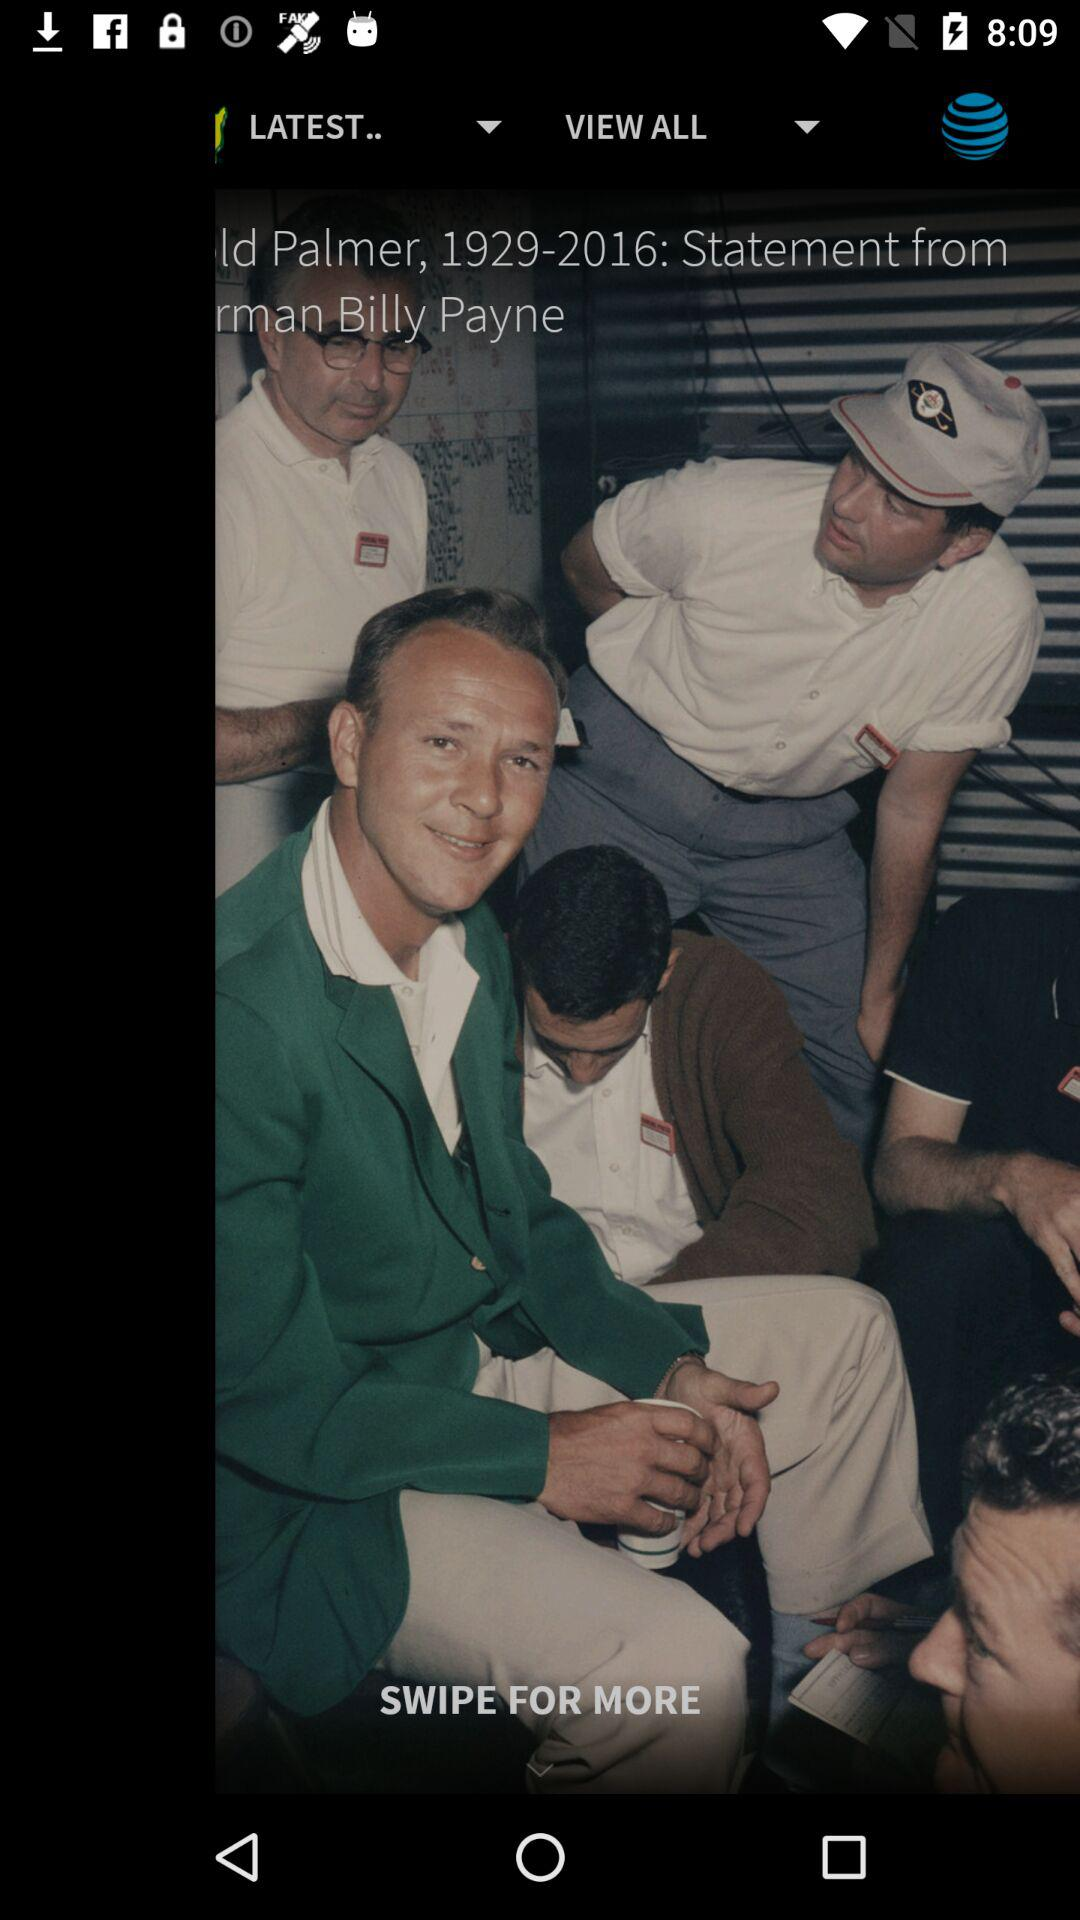For shot 1, how many YDS are there? There are 283 yards for shot 1. 